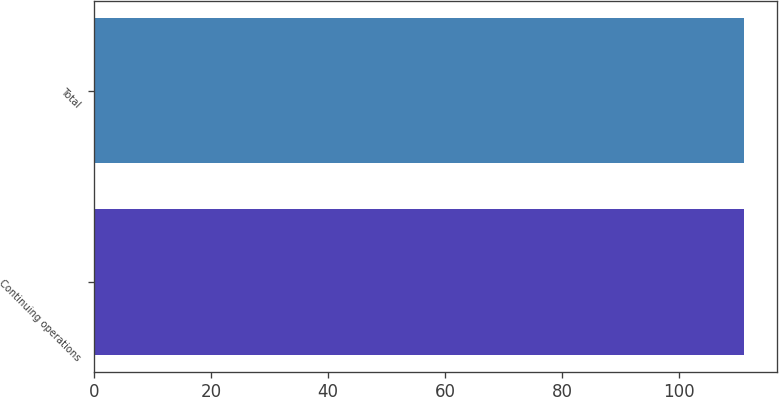<chart> <loc_0><loc_0><loc_500><loc_500><bar_chart><fcel>Continuing operations<fcel>Total<nl><fcel>111<fcel>111.1<nl></chart> 